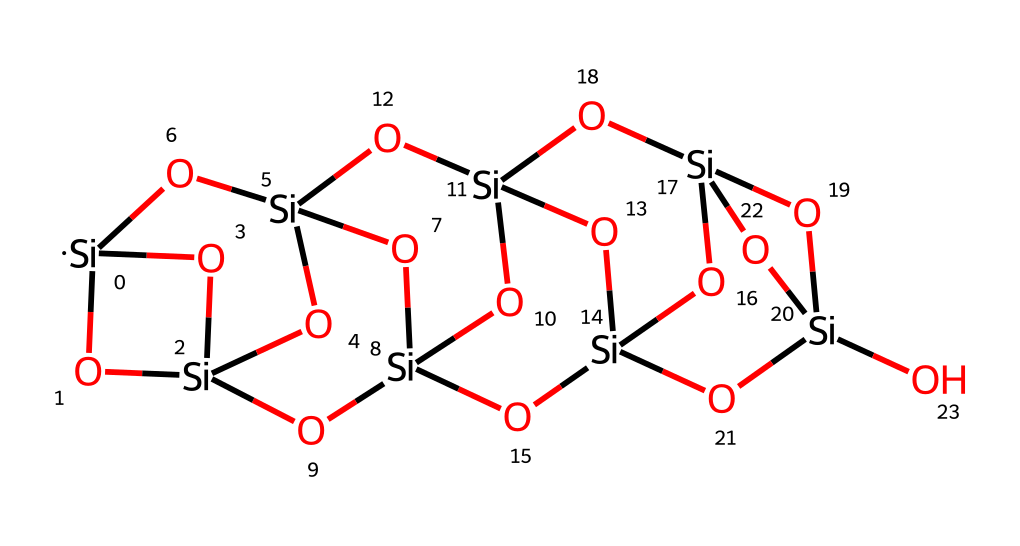What is the main element present in this structure? The structure primarily consists of silicon atoms, as indicated by the multiple occurrences of the symbol [Si] in the SMILES representation.
Answer: silicon How many oxygen atoms are present in this compound? By examining the SMILES, we count the occurrences of the symbol "O," which appears eight times, indicating there are eight oxygen atoms in the structure.
Answer: eight What type of structure does this compound represent? The SMILES notation suggests a polyhedral oligomeric silsesquioxane structure due to the arrangement of silicon and oxygen in a cage-like formation typical of POSS compounds.
Answer: POSS How many silicon atoms are there in total? The SMILES representation includes ten instances of the symbol [Si], indicating that there are ten silicon atoms in the compound.
Answer: ten What feature of the structure indicates it is a cage compound? The presence of interconnected silicon and oxygen atoms forming a closed polyhedral shape, as suggested by the notation, is indicative of a cage compound.
Answer: interconnected How does this compound contribute to biodegradability in plastics? The incorporation of POSS compounds can enhance the mechanical properties and thermal stability of biodegradable plastics while still maintaining a lower environmental impact, thanks to their silicon-oxygen linkages which can degrade more easily than conventional plastics.
Answer: enhances properties What part of the structure allows it to be utilized in materials science? The cage-like architecture provide unique properties, such as increased rigidity and thermal stability, making it suitable for use in advanced material applications.
Answer: cage-like architecture 